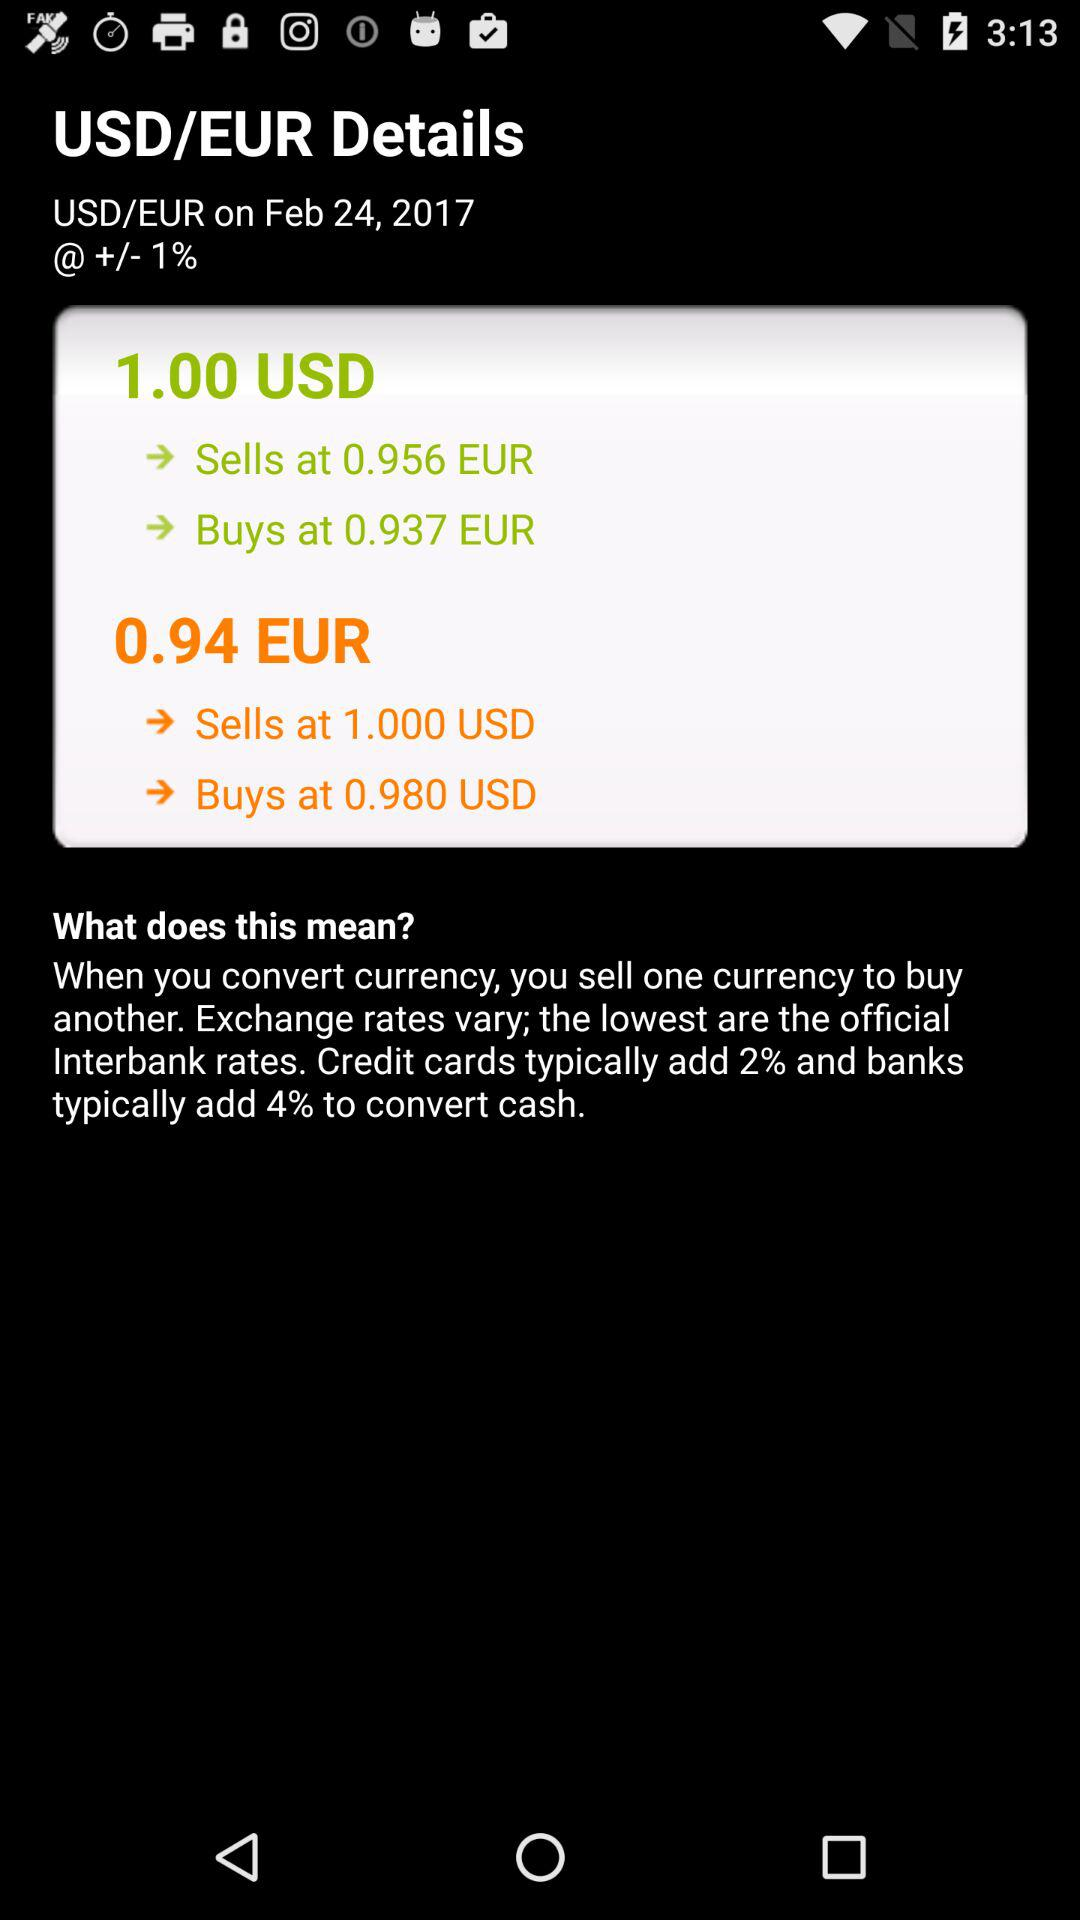What is the value of the euro against $1? The values of the euro against $1 are 0.956 and 0.937. 